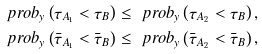<formula> <loc_0><loc_0><loc_500><loc_500>& \ p r o b _ { y } \left ( \tau _ { A _ { 1 } } < \tau _ { B } \right ) \leq \ p r o b _ { y } \left ( \tau _ { A _ { 2 } } < \tau _ { B } \right ) , \\ & \ p r o b _ { y } \left ( \bar { \tau } _ { A _ { 1 } } < \bar { \tau } _ { B } \right ) \leq \ p r o b _ { y } \left ( \bar { \tau } _ { A _ { 2 } } < \bar { \tau } _ { B } \right ) ,</formula> 